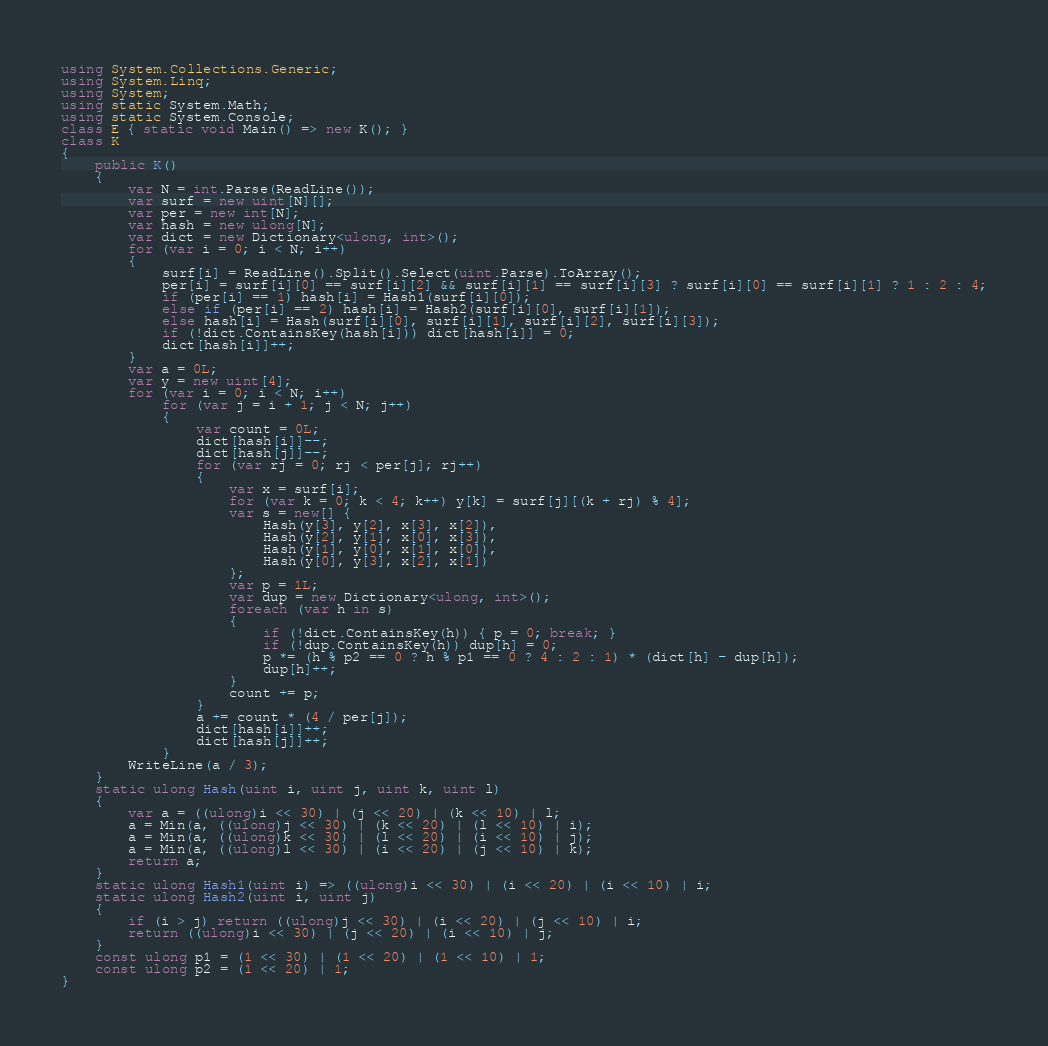Convert code to text. <code><loc_0><loc_0><loc_500><loc_500><_C#_>using System.Collections.Generic;
using System.Linq;
using System;
using static System.Math;
using static System.Console;
class E { static void Main() => new K(); }
class K
{
	public K()
	{
		var N = int.Parse(ReadLine());
		var surf = new uint[N][];
		var per = new int[N];
		var hash = new ulong[N];
		var dict = new Dictionary<ulong, int>();
		for (var i = 0; i < N; i++)
		{
			surf[i] = ReadLine().Split().Select(uint.Parse).ToArray();
			per[i] = surf[i][0] == surf[i][2] && surf[i][1] == surf[i][3] ? surf[i][0] == surf[i][1] ? 1 : 2 : 4;
			if (per[i] == 1) hash[i] = Hash1(surf[i][0]);
			else if (per[i] == 2) hash[i] = Hash2(surf[i][0], surf[i][1]);
			else hash[i] = Hash(surf[i][0], surf[i][1], surf[i][2], surf[i][3]);
			if (!dict.ContainsKey(hash[i])) dict[hash[i]] = 0;
			dict[hash[i]]++;
		}
		var a = 0L;
		var y = new uint[4];
		for (var i = 0; i < N; i++)
			for (var j = i + 1; j < N; j++)
			{
				var count = 0L;
				dict[hash[i]]--;
				dict[hash[j]]--;
				for (var rj = 0; rj < per[j]; rj++)
				{
					var x = surf[i];
					for (var k = 0; k < 4; k++) y[k] = surf[j][(k + rj) % 4];
					var s = new[] {
						Hash(y[3], y[2], x[3], x[2]),
						Hash(y[2], y[1], x[0], x[3]),
						Hash(y[1], y[0], x[1], x[0]),
						Hash(y[0], y[3], x[2], x[1])
					};
					var p = 1L;
					var dup = new Dictionary<ulong, int>();
					foreach (var h in s)
					{
						if (!dict.ContainsKey(h)) { p = 0; break; }
						if (!dup.ContainsKey(h)) dup[h] = 0;
						p *= (h % p2 == 0 ? h % p1 == 0 ? 4 : 2 : 1) * (dict[h] - dup[h]);
						dup[h]++;
					}
					count += p;
				}
				a += count * (4 / per[j]);
				dict[hash[i]]++;
				dict[hash[j]]++;
			}
		WriteLine(a / 3);
	}
	static ulong Hash(uint i, uint j, uint k, uint l)
	{
		var a = ((ulong)i << 30) | (j << 20) | (k << 10) | l;
		a = Min(a, ((ulong)j << 30) | (k << 20) | (l << 10) | i);
		a = Min(a, ((ulong)k << 30) | (l << 20) | (i << 10) | j);
		a = Min(a, ((ulong)l << 30) | (i << 20) | (j << 10) | k);
		return a;
	}
	static ulong Hash1(uint i) => ((ulong)i << 30) | (i << 20) | (i << 10) | i;
	static ulong Hash2(uint i, uint j)
	{
		if (i > j) return ((ulong)j << 30) | (i << 20) | (j << 10) | i;
		return ((ulong)i << 30) | (j << 20) | (i << 10) | j;
	}
	const ulong p1 = (1 << 30) | (1 << 20) | (1 << 10) | 1;
	const ulong p2 = (1 << 20) | 1;
}
</code> 